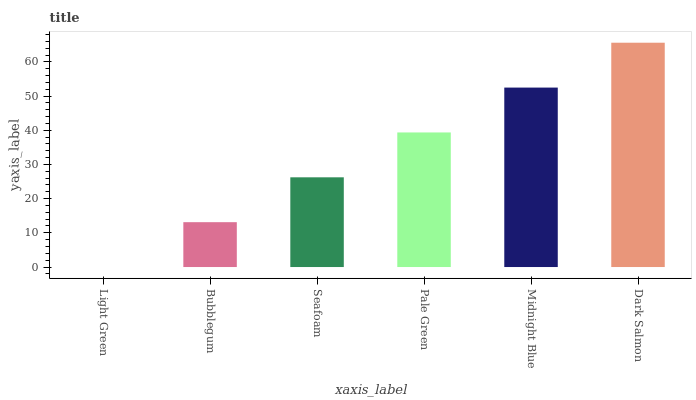Is Light Green the minimum?
Answer yes or no. Yes. Is Dark Salmon the maximum?
Answer yes or no. Yes. Is Bubblegum the minimum?
Answer yes or no. No. Is Bubblegum the maximum?
Answer yes or no. No. Is Bubblegum greater than Light Green?
Answer yes or no. Yes. Is Light Green less than Bubblegum?
Answer yes or no. Yes. Is Light Green greater than Bubblegum?
Answer yes or no. No. Is Bubblegum less than Light Green?
Answer yes or no. No. Is Pale Green the high median?
Answer yes or no. Yes. Is Seafoam the low median?
Answer yes or no. Yes. Is Midnight Blue the high median?
Answer yes or no. No. Is Dark Salmon the low median?
Answer yes or no. No. 